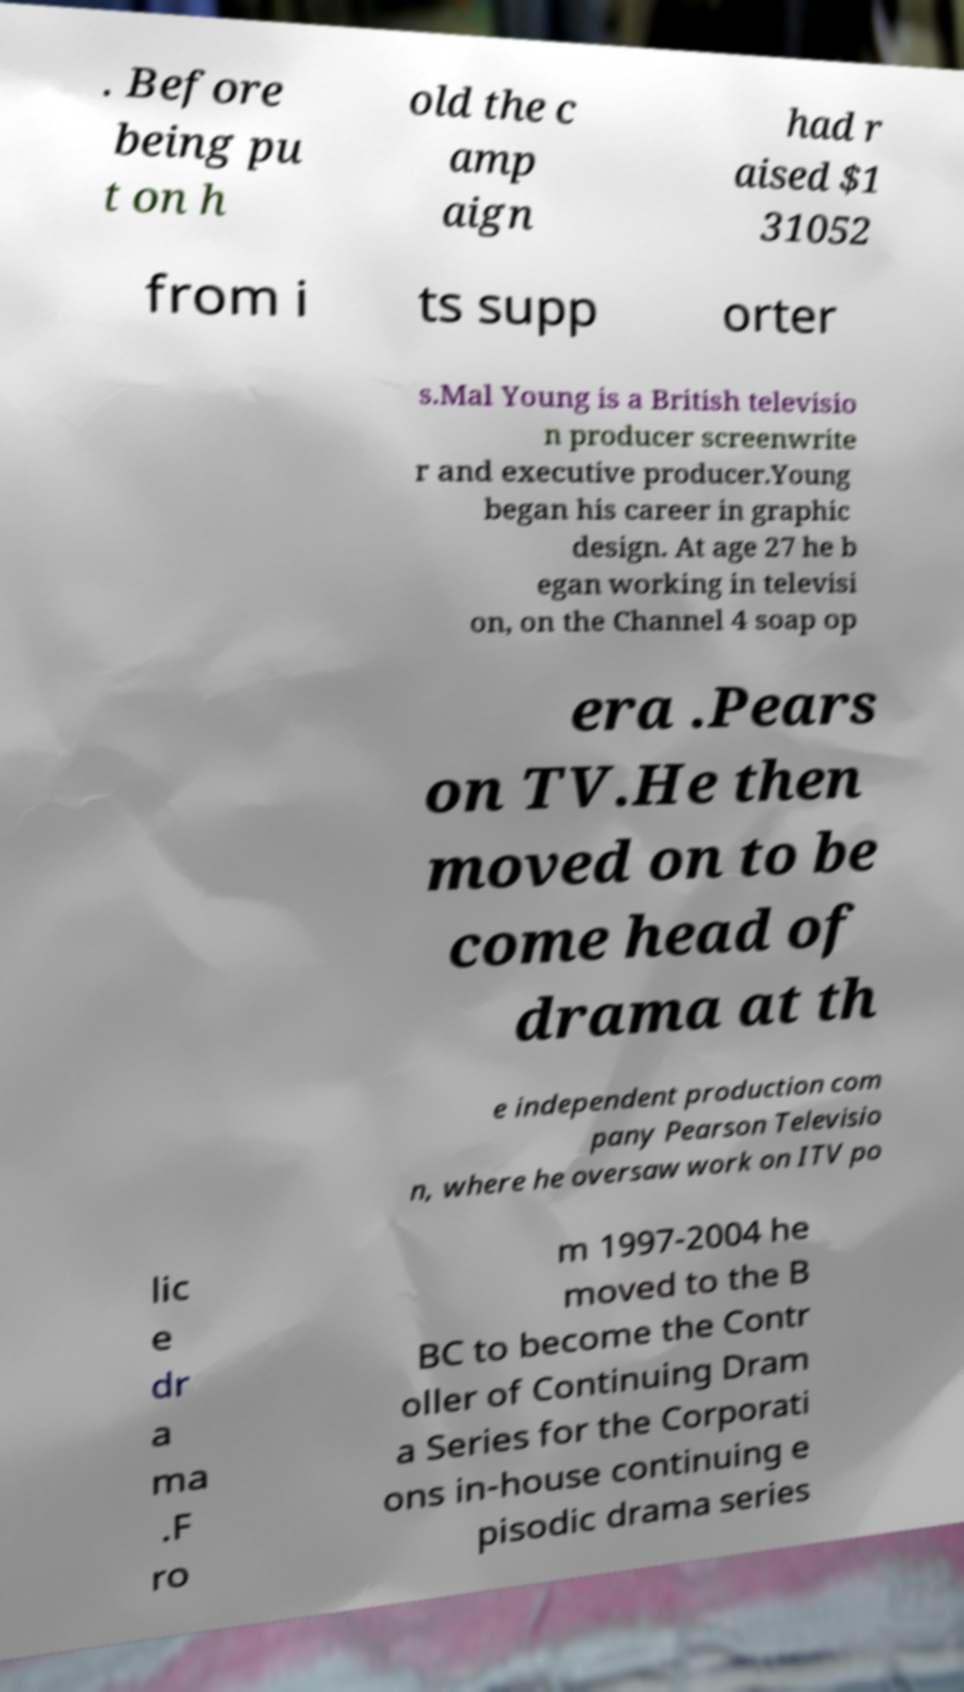I need the written content from this picture converted into text. Can you do that? . Before being pu t on h old the c amp aign had r aised $1 31052 from i ts supp orter s.Mal Young is a British televisio n producer screenwrite r and executive producer.Young began his career in graphic design. At age 27 he b egan working in televisi on, on the Channel 4 soap op era .Pears on TV.He then moved on to be come head of drama at th e independent production com pany Pearson Televisio n, where he oversaw work on ITV po lic e dr a ma .F ro m 1997-2004 he moved to the B BC to become the Contr oller of Continuing Dram a Series for the Corporati ons in-house continuing e pisodic drama series 